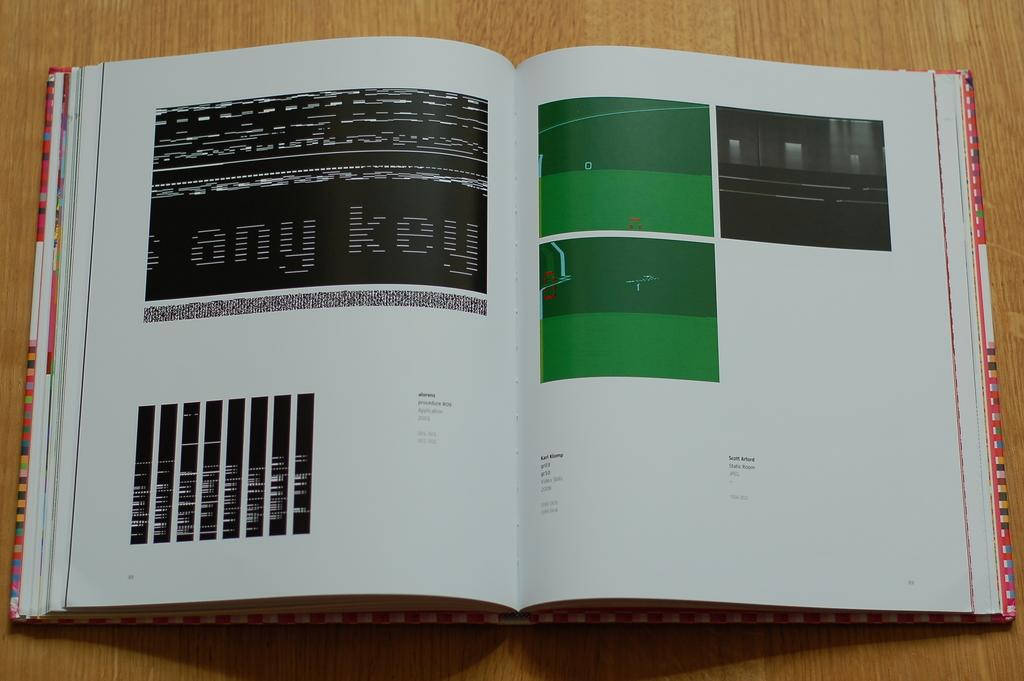Provide a one-sentence caption for the provided image. A book open to page 88 with the words "any key" in large print. 